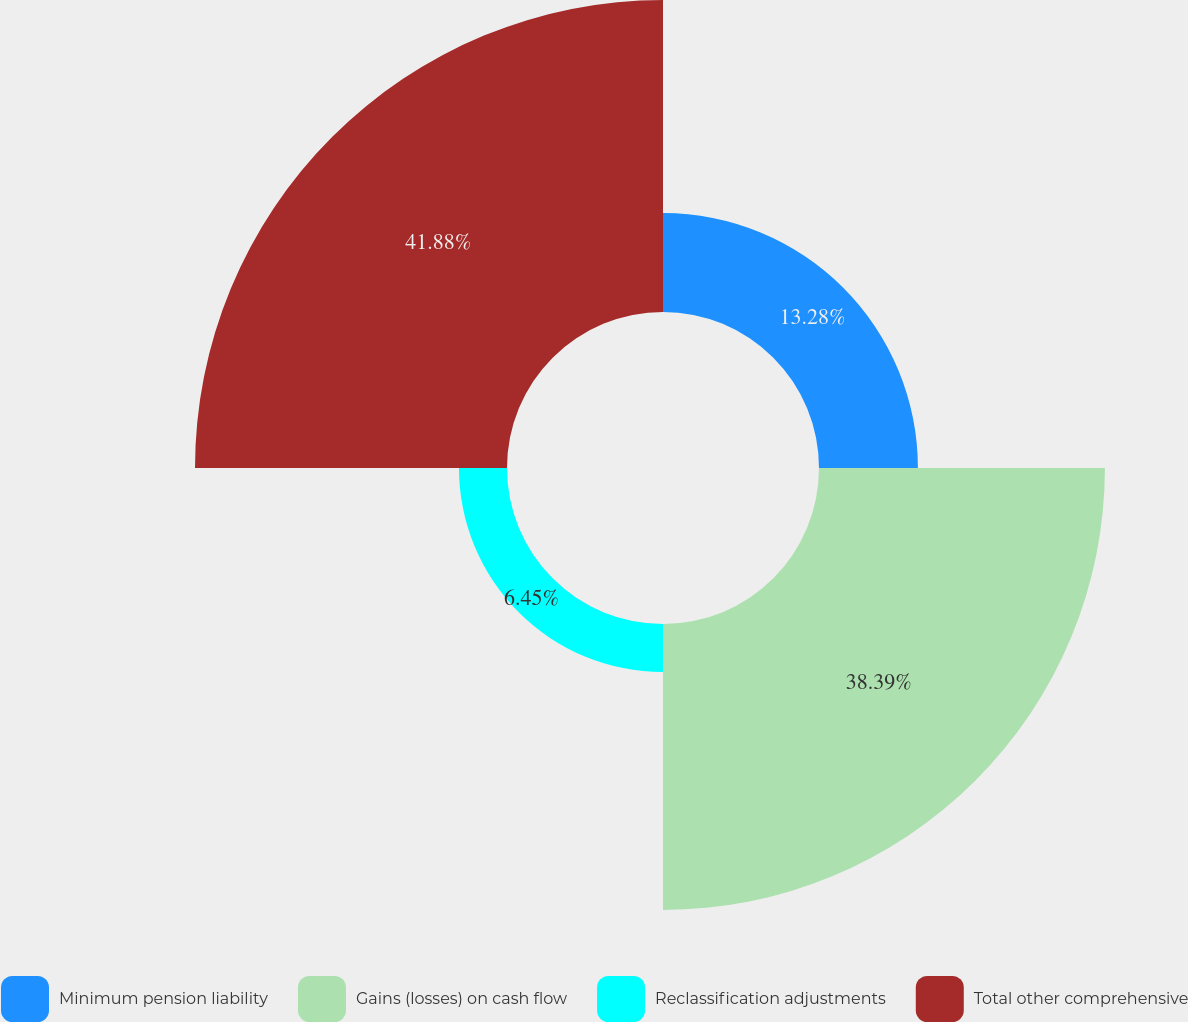<chart> <loc_0><loc_0><loc_500><loc_500><pie_chart><fcel>Minimum pension liability<fcel>Gains (losses) on cash flow<fcel>Reclassification adjustments<fcel>Total other comprehensive<nl><fcel>13.28%<fcel>38.39%<fcel>6.45%<fcel>41.89%<nl></chart> 